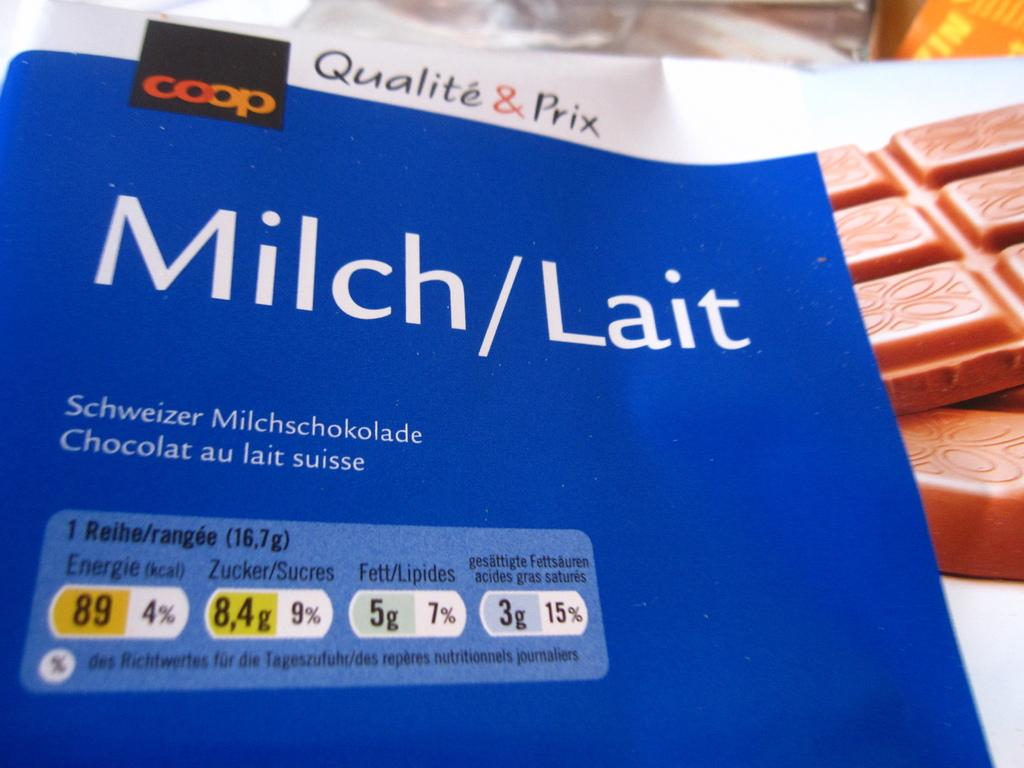What type of food is present on the white table in the image? There are chocolates on a white table in the image. What else can be seen on the floor in the image? There are objects on the floor in the image. What type of cards are on the table in the image? There is a white card with text and a blue card with text and numbers on the table in the image. What type of pie is being served at the harbor in the image? There is no pie or harbor present in the image. How many doors can be seen in the image? There are no doors visible in the image. 